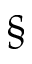<formula> <loc_0><loc_0><loc_500><loc_500>\S</formula> 